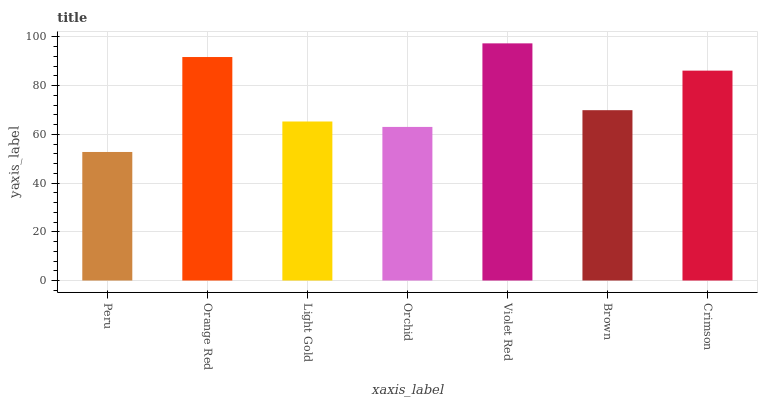Is Peru the minimum?
Answer yes or no. Yes. Is Violet Red the maximum?
Answer yes or no. Yes. Is Orange Red the minimum?
Answer yes or no. No. Is Orange Red the maximum?
Answer yes or no. No. Is Orange Red greater than Peru?
Answer yes or no. Yes. Is Peru less than Orange Red?
Answer yes or no. Yes. Is Peru greater than Orange Red?
Answer yes or no. No. Is Orange Red less than Peru?
Answer yes or no. No. Is Brown the high median?
Answer yes or no. Yes. Is Brown the low median?
Answer yes or no. Yes. Is Orchid the high median?
Answer yes or no. No. Is Peru the low median?
Answer yes or no. No. 